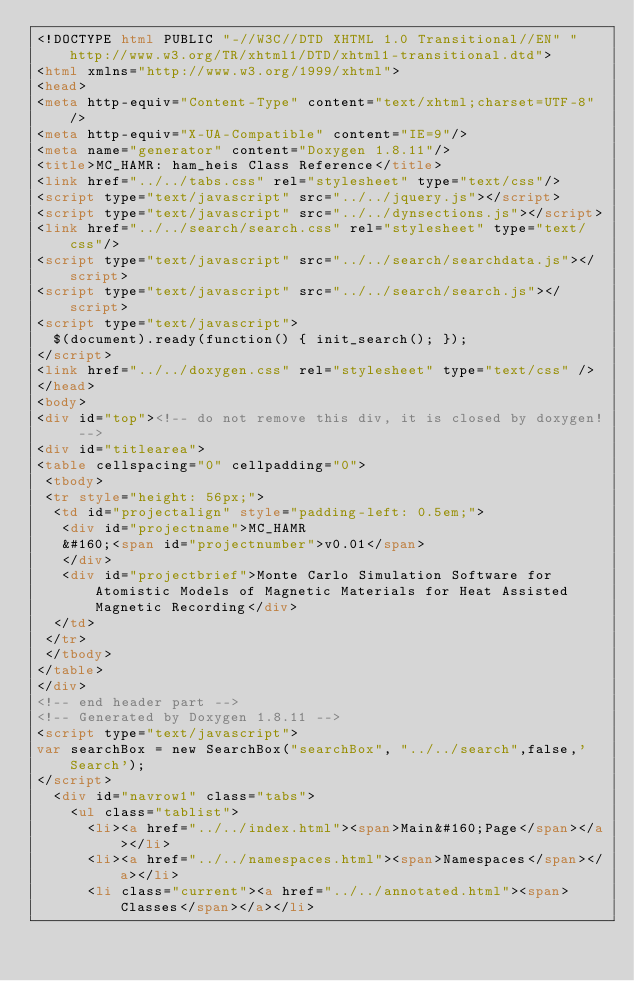<code> <loc_0><loc_0><loc_500><loc_500><_HTML_><!DOCTYPE html PUBLIC "-//W3C//DTD XHTML 1.0 Transitional//EN" "http://www.w3.org/TR/xhtml1/DTD/xhtml1-transitional.dtd">
<html xmlns="http://www.w3.org/1999/xhtml">
<head>
<meta http-equiv="Content-Type" content="text/xhtml;charset=UTF-8"/>
<meta http-equiv="X-UA-Compatible" content="IE=9"/>
<meta name="generator" content="Doxygen 1.8.11"/>
<title>MC_HAMR: ham_heis Class Reference</title>
<link href="../../tabs.css" rel="stylesheet" type="text/css"/>
<script type="text/javascript" src="../../jquery.js"></script>
<script type="text/javascript" src="../../dynsections.js"></script>
<link href="../../search/search.css" rel="stylesheet" type="text/css"/>
<script type="text/javascript" src="../../search/searchdata.js"></script>
<script type="text/javascript" src="../../search/search.js"></script>
<script type="text/javascript">
  $(document).ready(function() { init_search(); });
</script>
<link href="../../doxygen.css" rel="stylesheet" type="text/css" />
</head>
<body>
<div id="top"><!-- do not remove this div, it is closed by doxygen! -->
<div id="titlearea">
<table cellspacing="0" cellpadding="0">
 <tbody>
 <tr style="height: 56px;">
  <td id="projectalign" style="padding-left: 0.5em;">
   <div id="projectname">MC_HAMR
   &#160;<span id="projectnumber">v0.01</span>
   </div>
   <div id="projectbrief">Monte Carlo Simulation Software for Atomistic Models of Magnetic Materials for Heat Assisted Magnetic Recording</div>
  </td>
 </tr>
 </tbody>
</table>
</div>
<!-- end header part -->
<!-- Generated by Doxygen 1.8.11 -->
<script type="text/javascript">
var searchBox = new SearchBox("searchBox", "../../search",false,'Search');
</script>
  <div id="navrow1" class="tabs">
    <ul class="tablist">
      <li><a href="../../index.html"><span>Main&#160;Page</span></a></li>
      <li><a href="../../namespaces.html"><span>Namespaces</span></a></li>
      <li class="current"><a href="../../annotated.html"><span>Classes</span></a></li></code> 